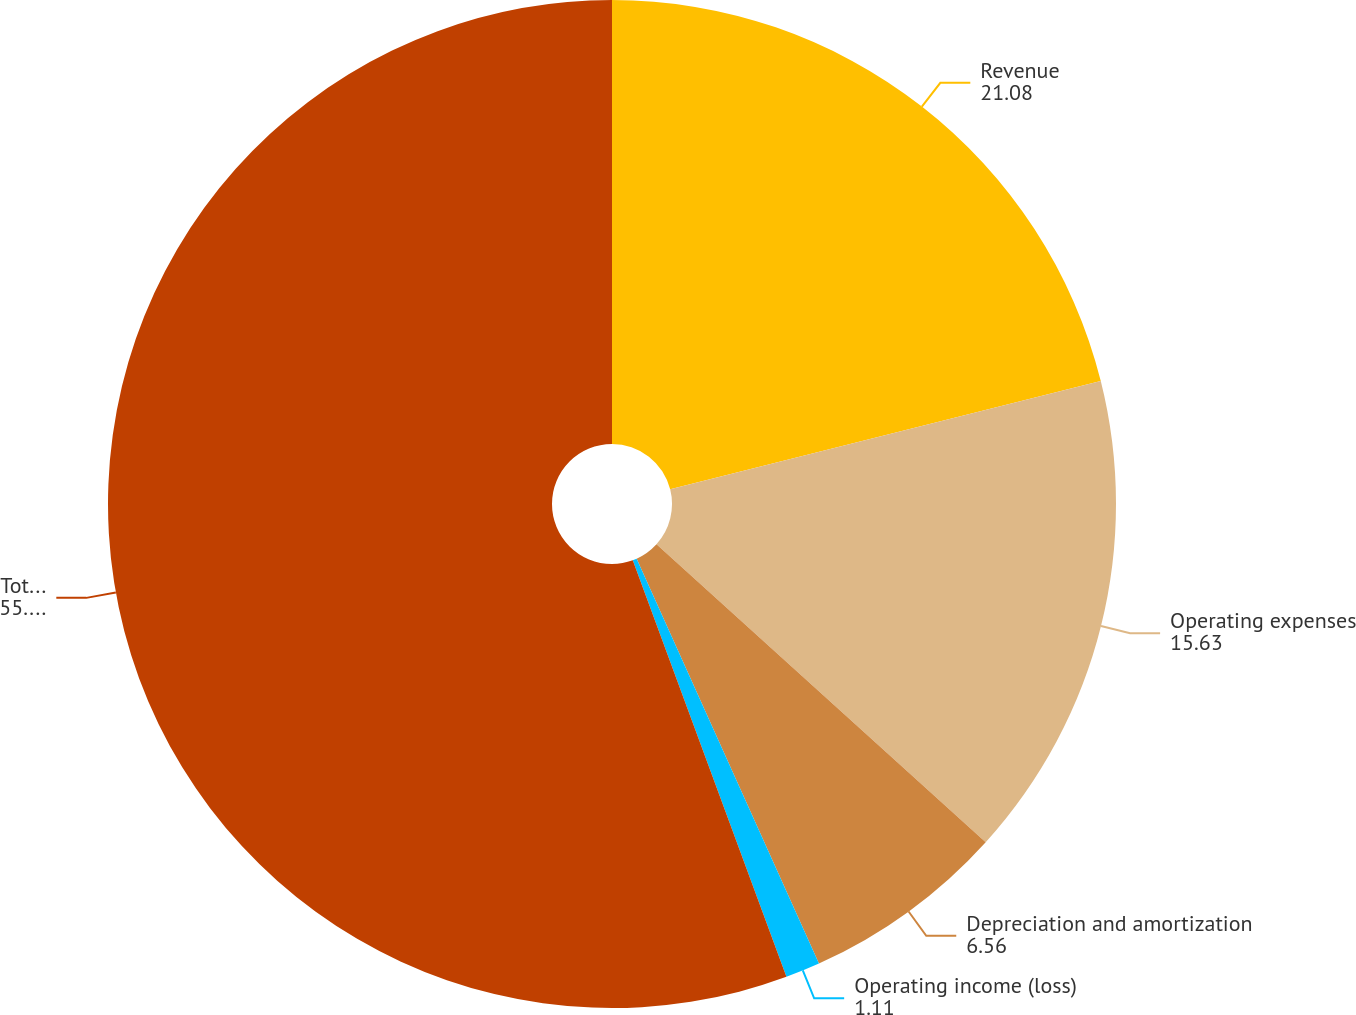Convert chart to OTSL. <chart><loc_0><loc_0><loc_500><loc_500><pie_chart><fcel>Revenue<fcel>Operating expenses<fcel>Depreciation and amortization<fcel>Operating income (loss)<fcel>Total assets at December 31<nl><fcel>21.08%<fcel>15.63%<fcel>6.56%<fcel>1.11%<fcel>55.63%<nl></chart> 